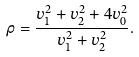Convert formula to latex. <formula><loc_0><loc_0><loc_500><loc_500>\rho = \frac { v _ { 1 } ^ { 2 } + v _ { 2 } ^ { 2 } + 4 v _ { 0 } ^ { 2 } } { v _ { 1 } ^ { 2 } + v _ { 2 } ^ { 2 } } .</formula> 